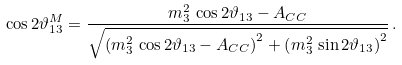Convert formula to latex. <formula><loc_0><loc_0><loc_500><loc_500>\cos 2 \vartheta _ { 1 3 } ^ { M } = \frac { m _ { 3 } ^ { 2 } \, \cos 2 \vartheta _ { 1 3 } - A _ { C C } } { \sqrt { \left ( m _ { 3 } ^ { 2 } \, \cos 2 \vartheta _ { 1 3 } - A _ { C C } \right ) ^ { 2 } + \left ( m _ { 3 } ^ { 2 } \, \sin 2 \vartheta _ { 1 3 } \right ) ^ { 2 } } } \, .</formula> 